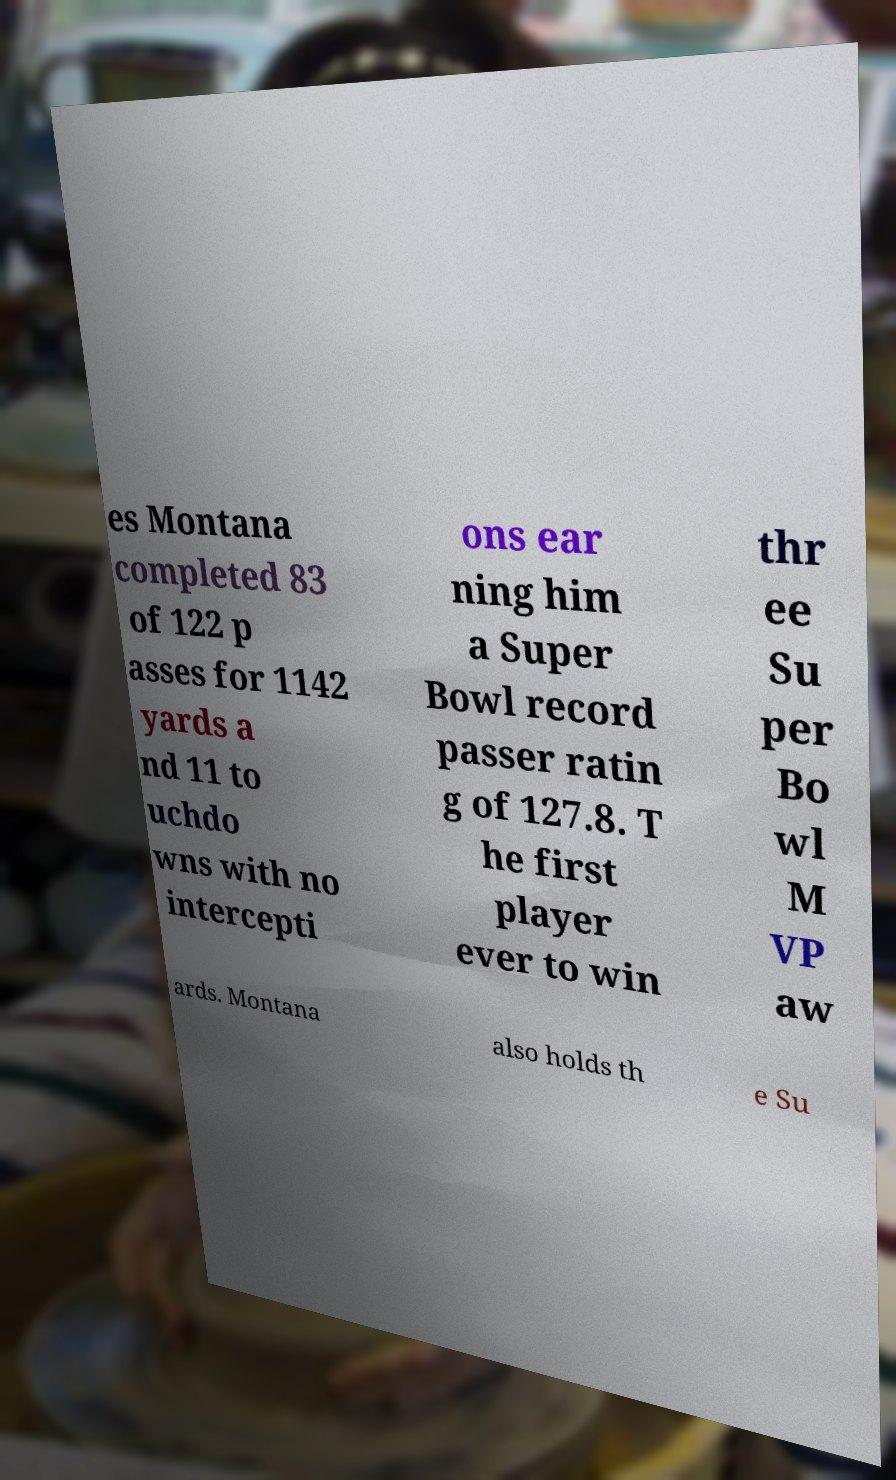Can you accurately transcribe the text from the provided image for me? es Montana completed 83 of 122 p asses for 1142 yards a nd 11 to uchdo wns with no intercepti ons ear ning him a Super Bowl record passer ratin g of 127.8. T he first player ever to win thr ee Su per Bo wl M VP aw ards. Montana also holds th e Su 